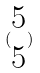<formula> <loc_0><loc_0><loc_500><loc_500>( \begin{matrix} 5 \\ 5 \end{matrix} )</formula> 